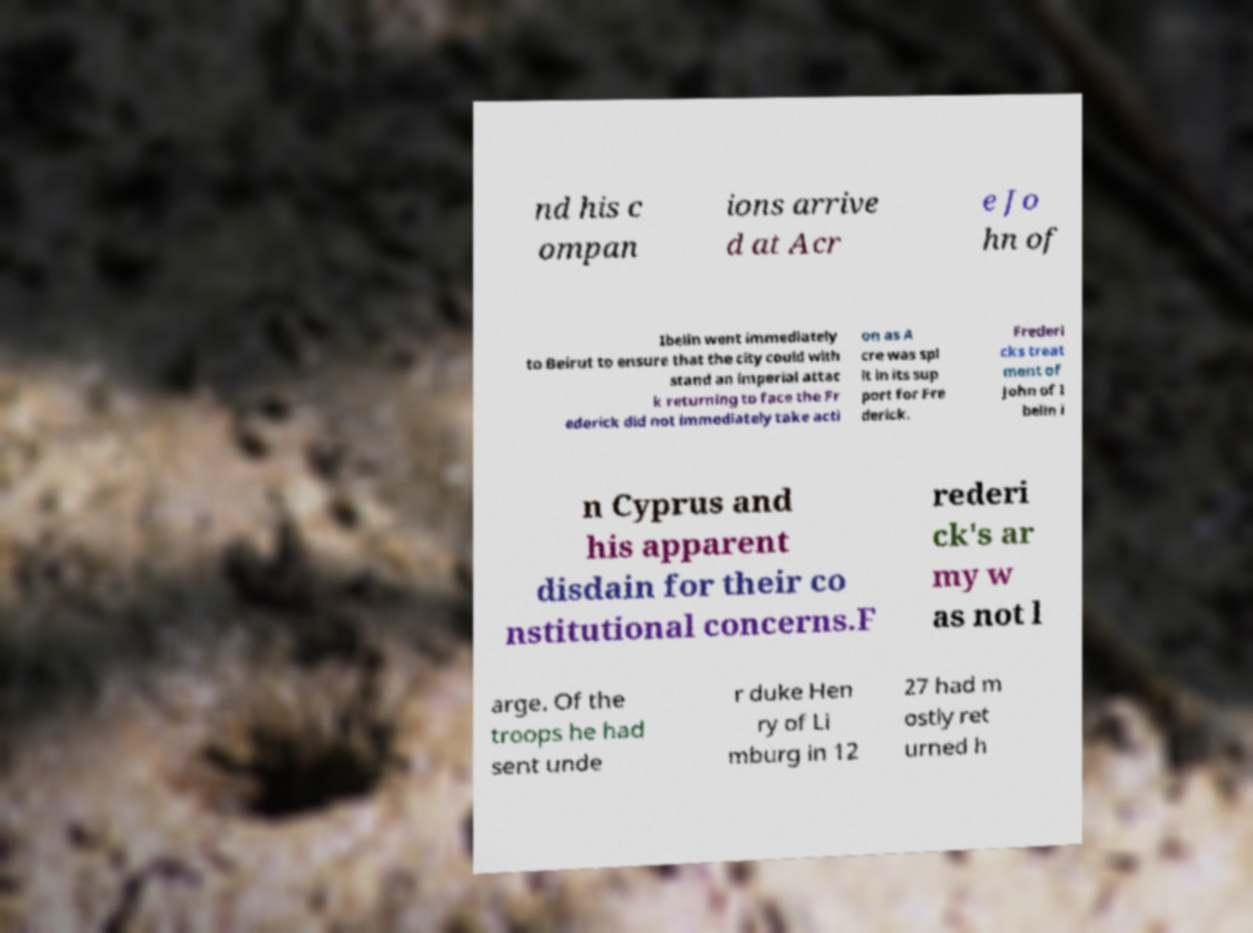Could you assist in decoding the text presented in this image and type it out clearly? nd his c ompan ions arrive d at Acr e Jo hn of Ibelin went immediately to Beirut to ensure that the city could with stand an imperial attac k returning to face the Fr ederick did not immediately take acti on as A cre was spl it in its sup port for Fre derick. Frederi cks treat ment of John of I belin i n Cyprus and his apparent disdain for their co nstitutional concerns.F rederi ck's ar my w as not l arge. Of the troops he had sent unde r duke Hen ry of Li mburg in 12 27 had m ostly ret urned h 